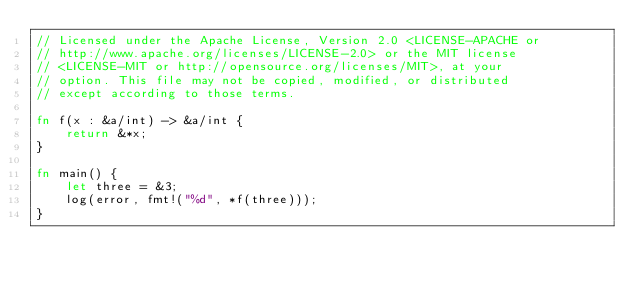<code> <loc_0><loc_0><loc_500><loc_500><_Rust_>// Licensed under the Apache License, Version 2.0 <LICENSE-APACHE or
// http://www.apache.org/licenses/LICENSE-2.0> or the MIT license
// <LICENSE-MIT or http://opensource.org/licenses/MIT>, at your
// option. This file may not be copied, modified, or distributed
// except according to those terms.

fn f(x : &a/int) -> &a/int {
    return &*x;
}

fn main() {
    let three = &3;
    log(error, fmt!("%d", *f(three)));
}

</code> 